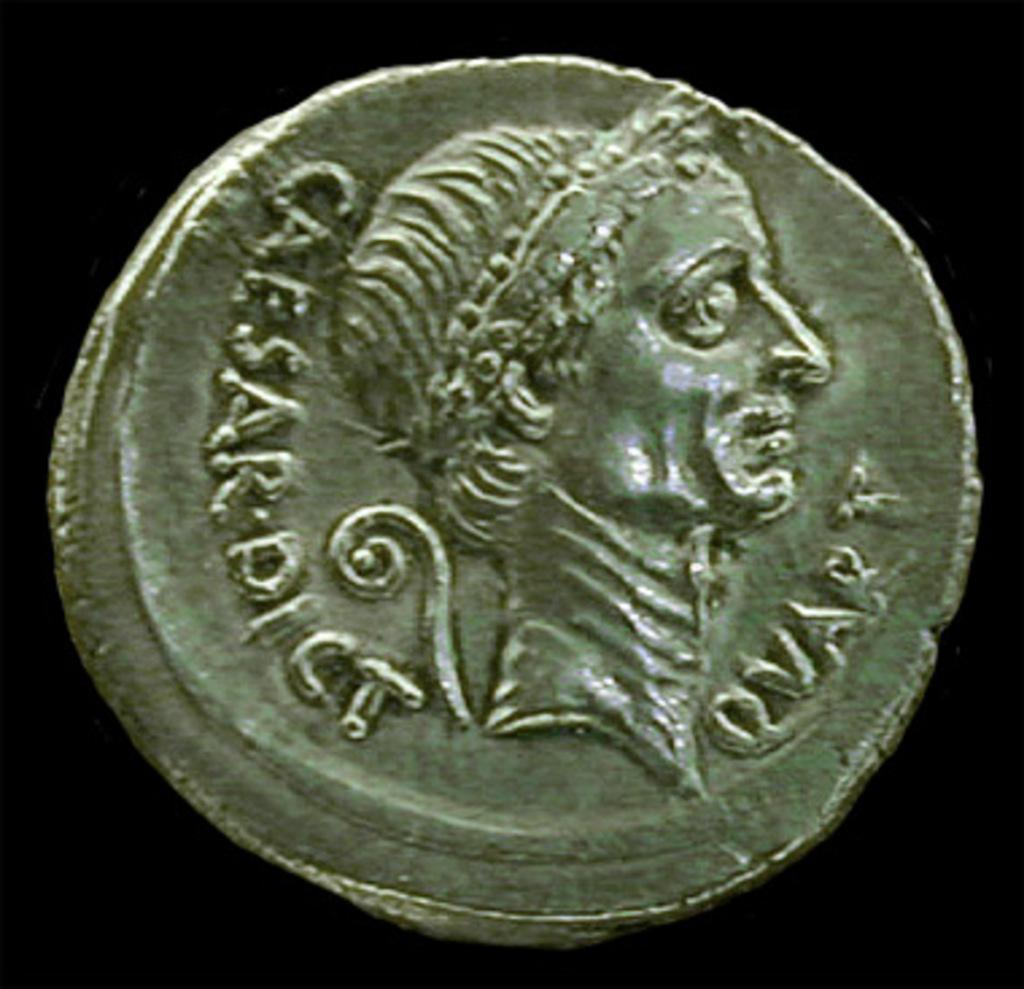<image>
Provide a brief description of the given image. an old roman coin with Caesar Dict Quart on it 